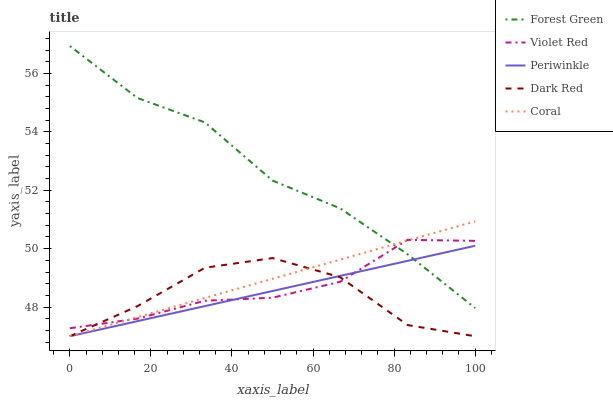Does Forest Green have the minimum area under the curve?
Answer yes or no. No. Does Dark Red have the maximum area under the curve?
Answer yes or no. No. Is Forest Green the smoothest?
Answer yes or no. No. Is Forest Green the roughest?
Answer yes or no. No. Does Forest Green have the lowest value?
Answer yes or no. No. Does Dark Red have the highest value?
Answer yes or no. No. Is Dark Red less than Forest Green?
Answer yes or no. Yes. Is Forest Green greater than Dark Red?
Answer yes or no. Yes. Does Dark Red intersect Forest Green?
Answer yes or no. No. 